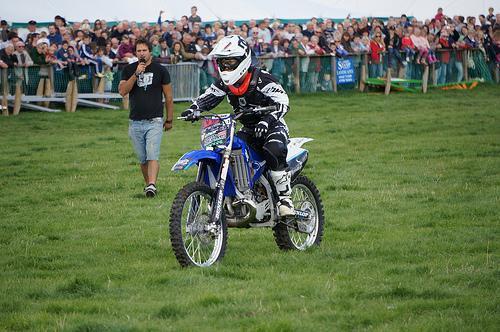How many motorcycles are in the scene?
Give a very brief answer. 1. How many wheels?
Give a very brief answer. 2. 